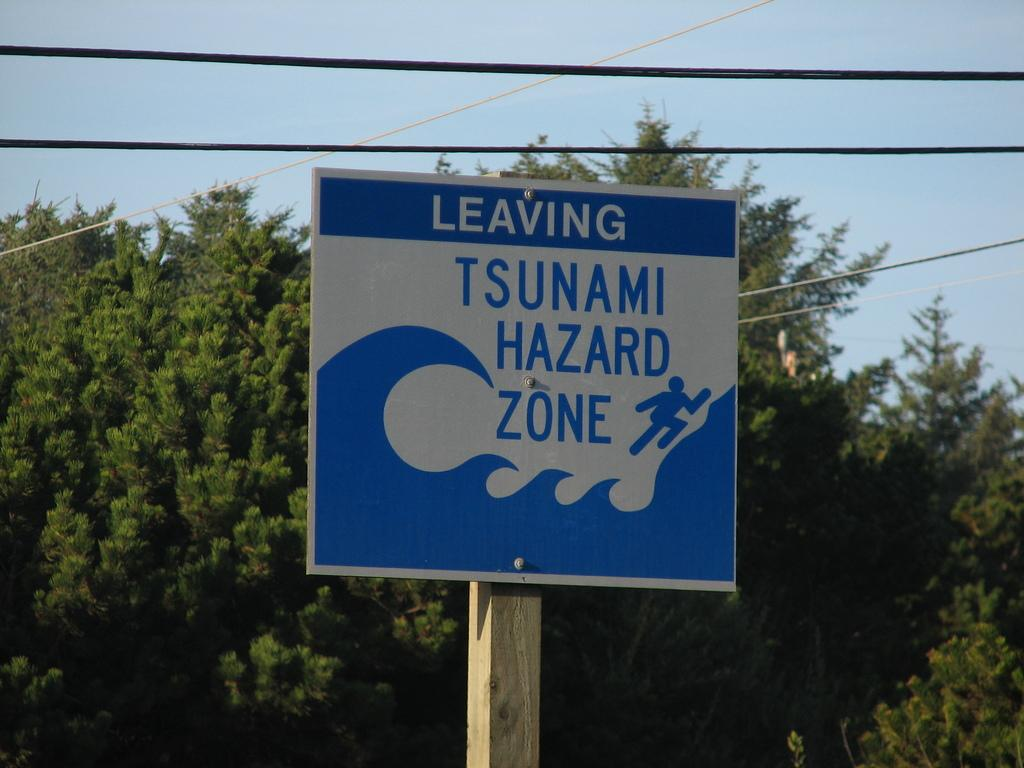What is attached to the pole in the image? There is a board attached to a pole in the image. What can be seen on the board? There is text on the board. What is located behind the pole in the image? There is a tree behind the pole. What is visible at the top of the image? The sky is visible at the top of the image. What else is present in the image besides the board and pole? Cable wires are present in the image. What type of guitar is being played in the image? There is no guitar present in the image. What kind of business is being conducted in the image? There is no business activity depicted in the image. 